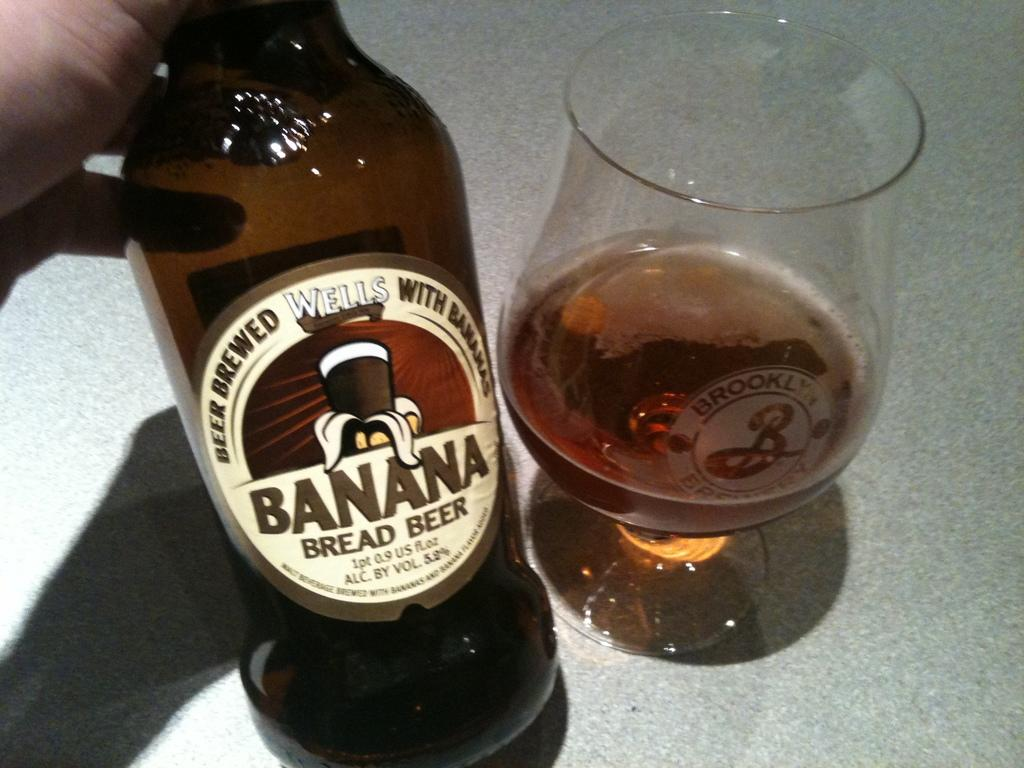<image>
Share a concise interpretation of the image provided. Banana Bread Beer that is Brewed Wells with Banana. 